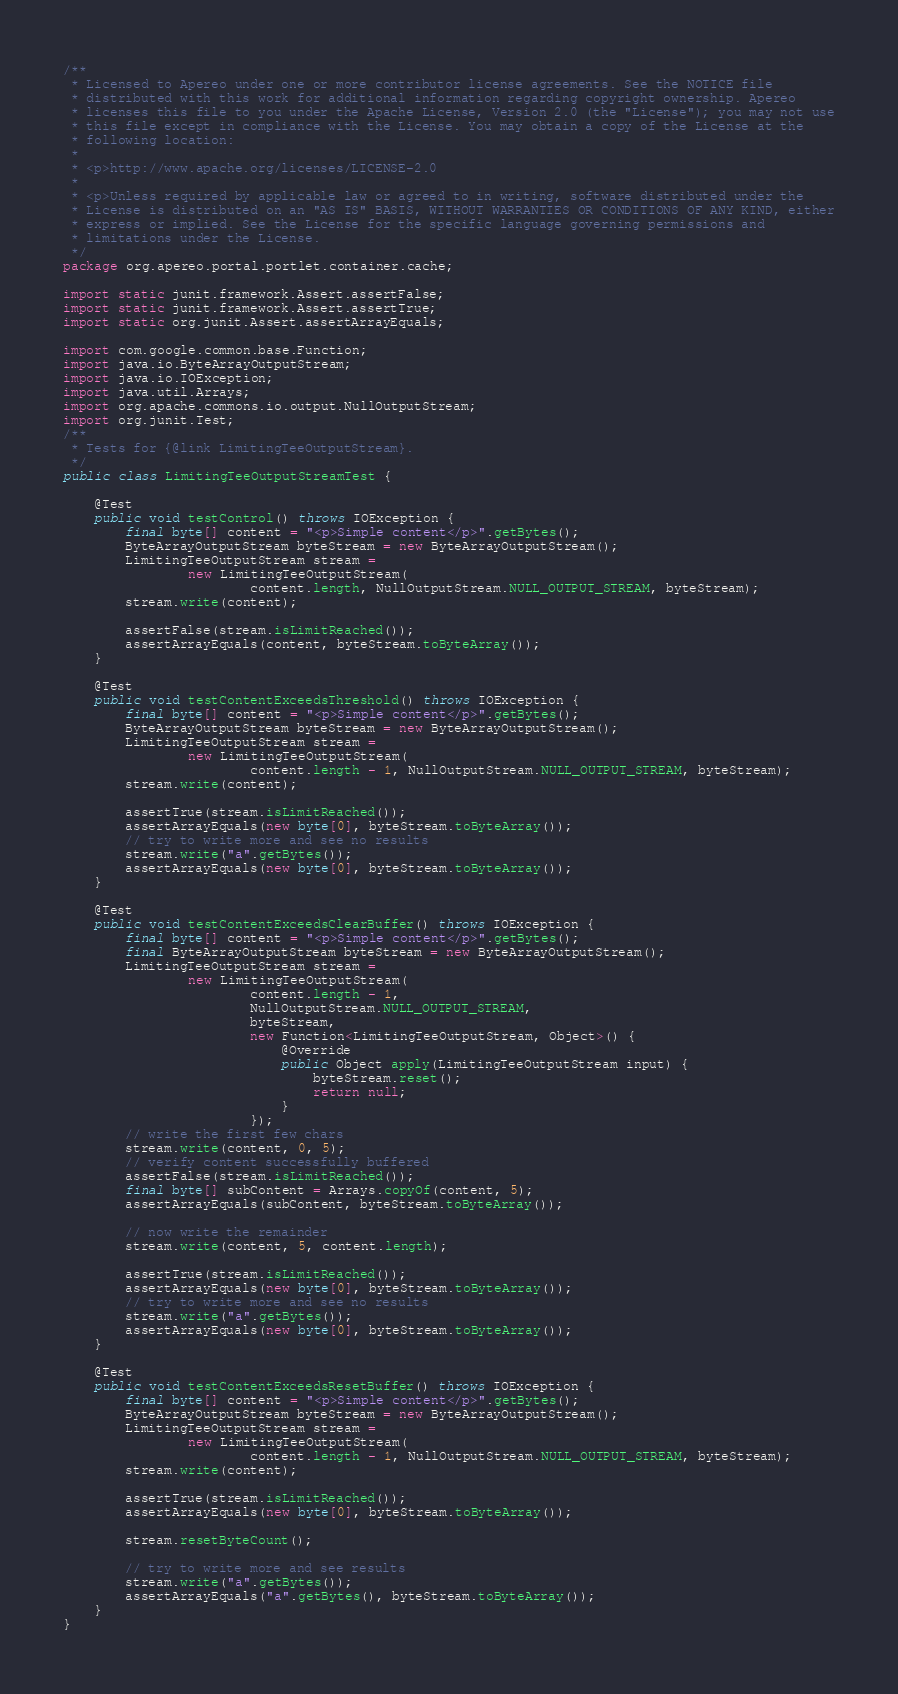<code> <loc_0><loc_0><loc_500><loc_500><_Java_>/**
 * Licensed to Apereo under one or more contributor license agreements. See the NOTICE file
 * distributed with this work for additional information regarding copyright ownership. Apereo
 * licenses this file to you under the Apache License, Version 2.0 (the "License"); you may not use
 * this file except in compliance with the License. You may obtain a copy of the License at the
 * following location:
 *
 * <p>http://www.apache.org/licenses/LICENSE-2.0
 *
 * <p>Unless required by applicable law or agreed to in writing, software distributed under the
 * License is distributed on an "AS IS" BASIS, WITHOUT WARRANTIES OR CONDITIONS OF ANY KIND, either
 * express or implied. See the License for the specific language governing permissions and
 * limitations under the License.
 */
package org.apereo.portal.portlet.container.cache;

import static junit.framework.Assert.assertFalse;
import static junit.framework.Assert.assertTrue;
import static org.junit.Assert.assertArrayEquals;

import com.google.common.base.Function;
import java.io.ByteArrayOutputStream;
import java.io.IOException;
import java.util.Arrays;
import org.apache.commons.io.output.NullOutputStream;
import org.junit.Test;
/**
 * Tests for {@link LimitingTeeOutputStream}.
 */
public class LimitingTeeOutputStreamTest {

    @Test
    public void testControl() throws IOException {
        final byte[] content = "<p>Simple content</p>".getBytes();
        ByteArrayOutputStream byteStream = new ByteArrayOutputStream();
        LimitingTeeOutputStream stream =
                new LimitingTeeOutputStream(
                        content.length, NullOutputStream.NULL_OUTPUT_STREAM, byteStream);
        stream.write(content);

        assertFalse(stream.isLimitReached());
        assertArrayEquals(content, byteStream.toByteArray());
    }

    @Test
    public void testContentExceedsThreshold() throws IOException {
        final byte[] content = "<p>Simple content</p>".getBytes();
        ByteArrayOutputStream byteStream = new ByteArrayOutputStream();
        LimitingTeeOutputStream stream =
                new LimitingTeeOutputStream(
                        content.length - 1, NullOutputStream.NULL_OUTPUT_STREAM, byteStream);
        stream.write(content);

        assertTrue(stream.isLimitReached());
        assertArrayEquals(new byte[0], byteStream.toByteArray());
        // try to write more and see no results
        stream.write("a".getBytes());
        assertArrayEquals(new byte[0], byteStream.toByteArray());
    }

    @Test
    public void testContentExceedsClearBuffer() throws IOException {
        final byte[] content = "<p>Simple content</p>".getBytes();
        final ByteArrayOutputStream byteStream = new ByteArrayOutputStream();
        LimitingTeeOutputStream stream =
                new LimitingTeeOutputStream(
                        content.length - 1,
                        NullOutputStream.NULL_OUTPUT_STREAM,
                        byteStream,
                        new Function<LimitingTeeOutputStream, Object>() {
                            @Override
                            public Object apply(LimitingTeeOutputStream input) {
                                byteStream.reset();
                                return null;
                            }
                        });
        // write the first few chars
        stream.write(content, 0, 5);
        // verify content successfully buffered
        assertFalse(stream.isLimitReached());
        final byte[] subContent = Arrays.copyOf(content, 5);
        assertArrayEquals(subContent, byteStream.toByteArray());

        // now write the remainder
        stream.write(content, 5, content.length);

        assertTrue(stream.isLimitReached());
        assertArrayEquals(new byte[0], byteStream.toByteArray());
        // try to write more and see no results
        stream.write("a".getBytes());
        assertArrayEquals(new byte[0], byteStream.toByteArray());
    }

    @Test
    public void testContentExceedsResetBuffer() throws IOException {
        final byte[] content = "<p>Simple content</p>".getBytes();
        ByteArrayOutputStream byteStream = new ByteArrayOutputStream();
        LimitingTeeOutputStream stream =
                new LimitingTeeOutputStream(
                        content.length - 1, NullOutputStream.NULL_OUTPUT_STREAM, byteStream);
        stream.write(content);

        assertTrue(stream.isLimitReached());
        assertArrayEquals(new byte[0], byteStream.toByteArray());

        stream.resetByteCount();

        // try to write more and see results
        stream.write("a".getBytes());
        assertArrayEquals("a".getBytes(), byteStream.toByteArray());
    }
}
</code> 